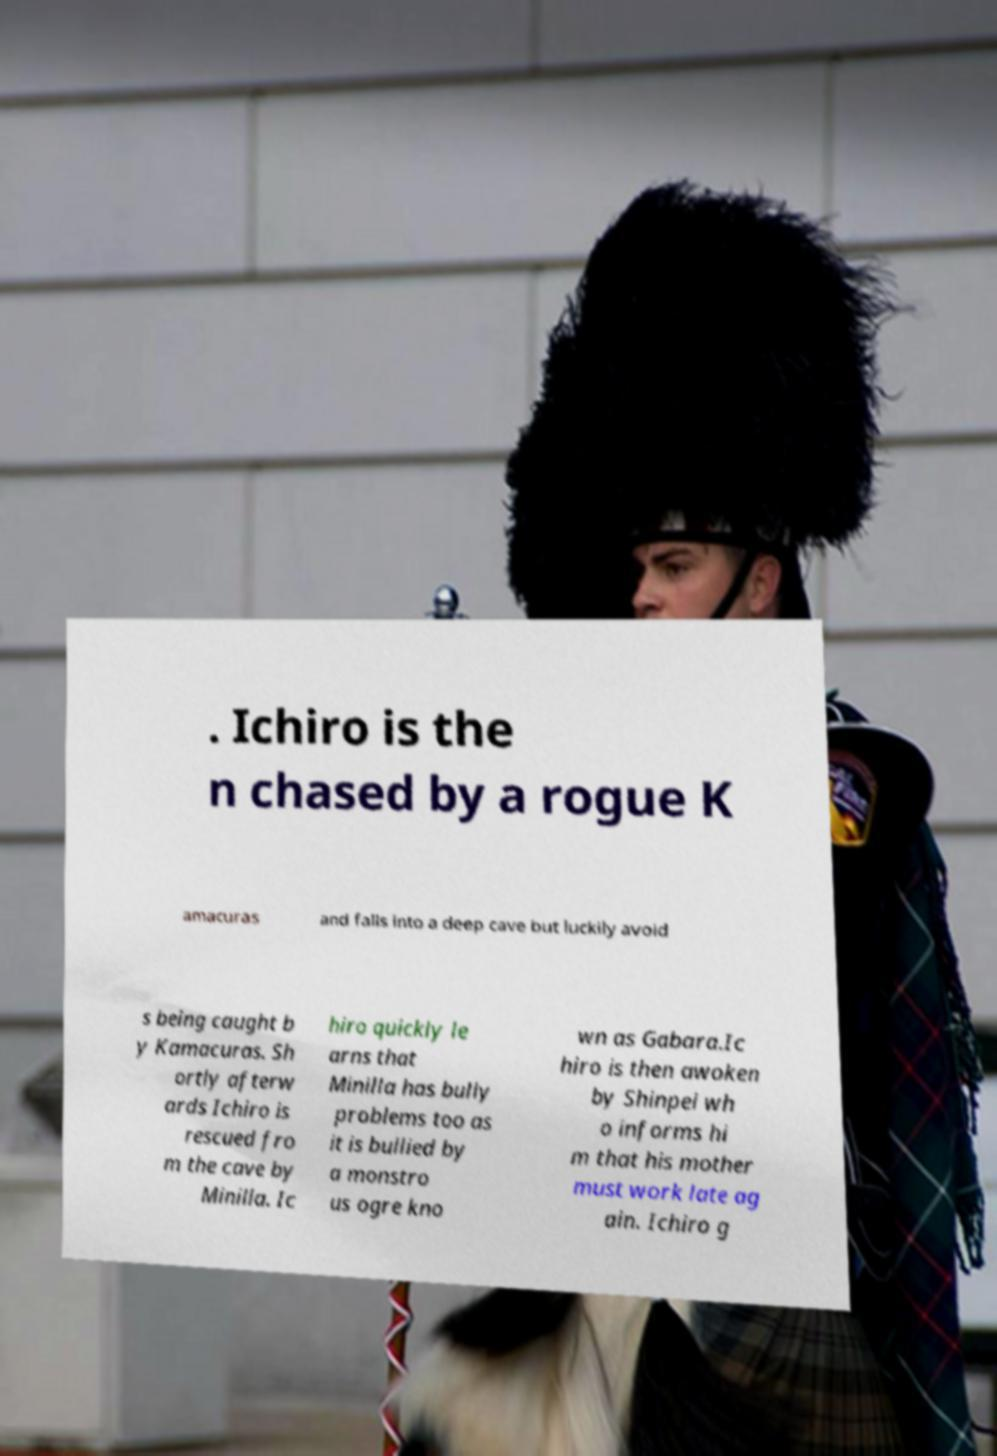Can you read and provide the text displayed in the image?This photo seems to have some interesting text. Can you extract and type it out for me? . Ichiro is the n chased by a rogue K amacuras and falls into a deep cave but luckily avoid s being caught b y Kamacuras. Sh ortly afterw ards Ichiro is rescued fro m the cave by Minilla. Ic hiro quickly le arns that Minilla has bully problems too as it is bullied by a monstro us ogre kno wn as Gabara.Ic hiro is then awoken by Shinpei wh o informs hi m that his mother must work late ag ain. Ichiro g 